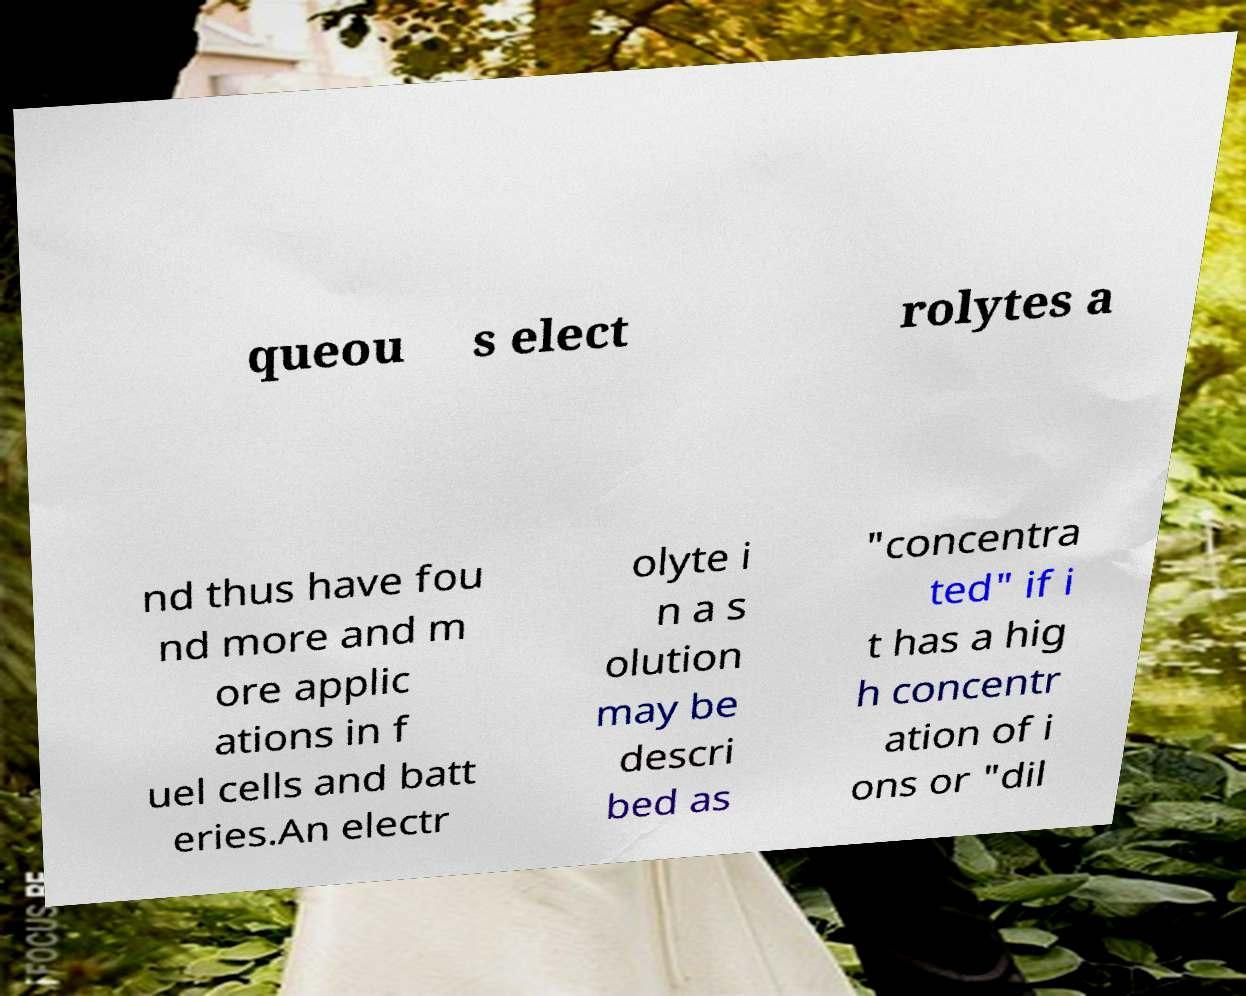Could you assist in decoding the text presented in this image and type it out clearly? queou s elect rolytes a nd thus have fou nd more and m ore applic ations in f uel cells and batt eries.An electr olyte i n a s olution may be descri bed as "concentra ted" if i t has a hig h concentr ation of i ons or "dil 